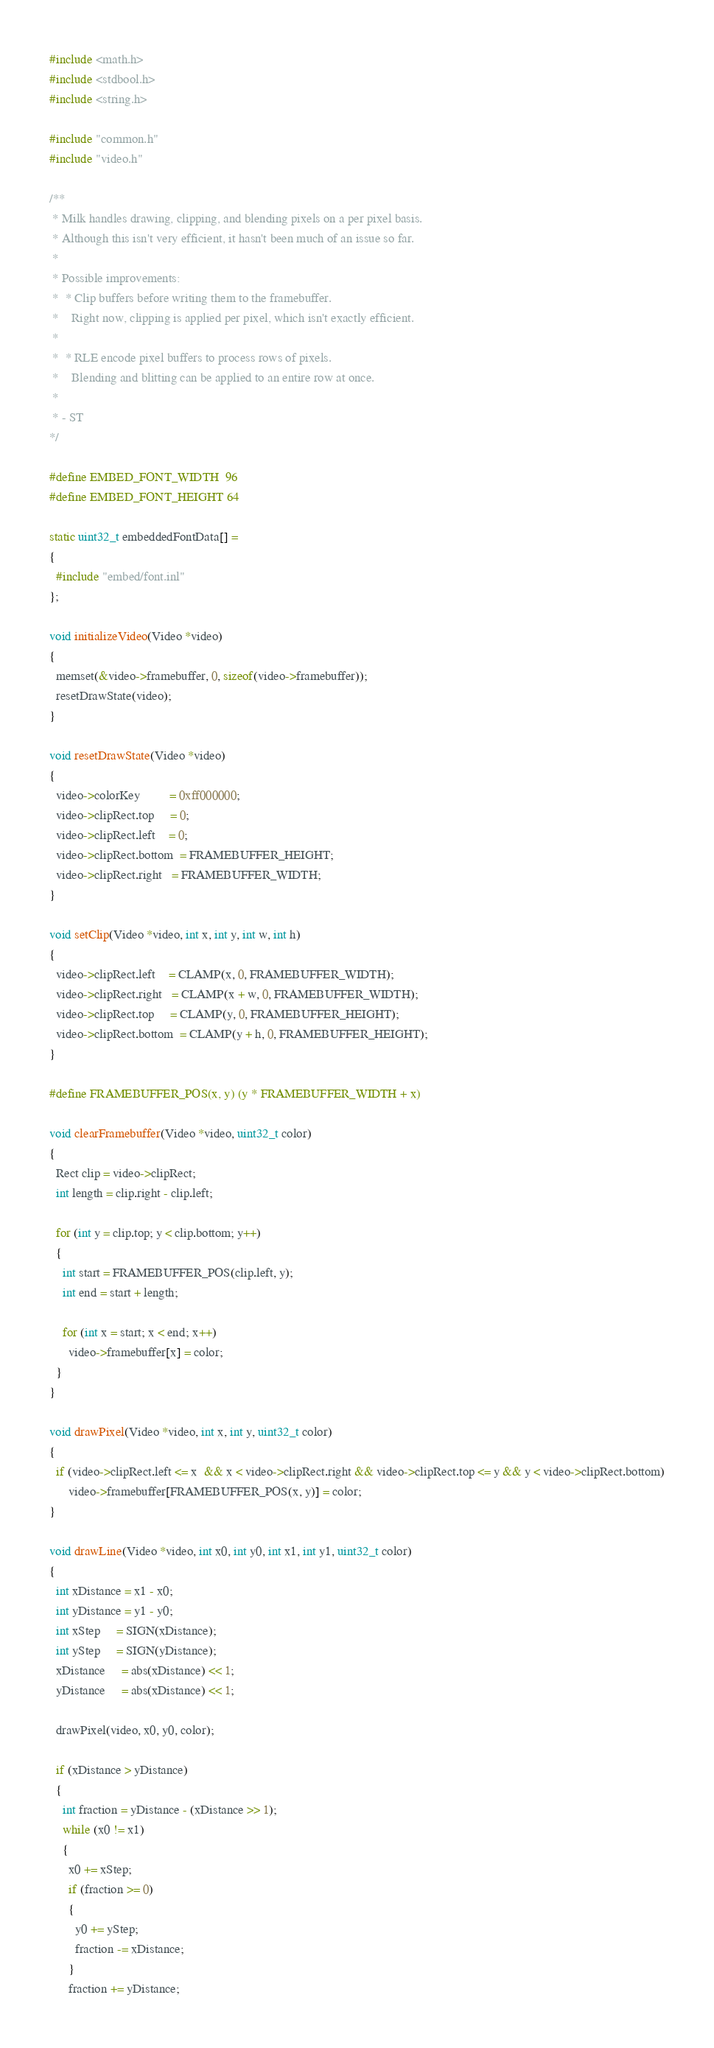<code> <loc_0><loc_0><loc_500><loc_500><_C_>#include <math.h>
#include <stdbool.h>
#include <string.h>

#include "common.h"
#include "video.h"

/**
 * Milk handles drawing, clipping, and blending pixels on a per pixel basis.
 * Although this isn't very efficient, it hasn't been much of an issue so far.
 *
 * Possible improvements:
 *  * Clip buffers before writing them to the framebuffer.
 *    Right now, clipping is applied per pixel, which isn't exactly efficient.
 *
 *  * RLE encode pixel buffers to process rows of pixels.
 *    Blending and blitting can be applied to an entire row at once.
 *
 * - ST
*/

#define EMBED_FONT_WIDTH  96
#define EMBED_FONT_HEIGHT 64

static uint32_t embeddedFontData[] =
{
  #include "embed/font.inl"
};

void initializeVideo(Video *video)
{
  memset(&video->framebuffer, 0, sizeof(video->framebuffer));
  resetDrawState(video);
}

void resetDrawState(Video *video)
{
  video->colorKey         = 0xff000000;
  video->clipRect.top     = 0;
  video->clipRect.left    = 0;
  video->clipRect.bottom  = FRAMEBUFFER_HEIGHT;
  video->clipRect.right   = FRAMEBUFFER_WIDTH;
}

void setClip(Video *video, int x, int y, int w, int h)
{
  video->clipRect.left    = CLAMP(x, 0, FRAMEBUFFER_WIDTH);
  video->clipRect.right   = CLAMP(x + w, 0, FRAMEBUFFER_WIDTH);
  video->clipRect.top     = CLAMP(y, 0, FRAMEBUFFER_HEIGHT);
  video->clipRect.bottom  = CLAMP(y + h, 0, FRAMEBUFFER_HEIGHT);
}

#define FRAMEBUFFER_POS(x, y) (y * FRAMEBUFFER_WIDTH + x)

void clearFramebuffer(Video *video, uint32_t color)
{
  Rect clip = video->clipRect;
  int length = clip.right - clip.left;

  for (int y = clip.top; y < clip.bottom; y++)
  {
    int start = FRAMEBUFFER_POS(clip.left, y);
    int end = start + length;

    for (int x = start; x < end; x++)
      video->framebuffer[x] = color;
  }
}

void drawPixel(Video *video, int x, int y, uint32_t color)
{
  if (video->clipRect.left <= x  && x < video->clipRect.right && video->clipRect.top <= y && y < video->clipRect.bottom)
      video->framebuffer[FRAMEBUFFER_POS(x, y)] = color;
}

void drawLine(Video *video, int x0, int y0, int x1, int y1, uint32_t color)
{
  int xDistance = x1 - x0;
  int yDistance = y1 - y0;
  int xStep     = SIGN(xDistance);
  int yStep     = SIGN(yDistance);
  xDistance     = abs(xDistance) << 1;
  yDistance     = abs(xDistance) << 1;

  drawPixel(video, x0, y0, color);

  if (xDistance > yDistance)
  {
    int fraction = yDistance - (xDistance >> 1);
    while (x0 != x1)
    {
      x0 += xStep;
      if (fraction >= 0)
      {
        y0 += yStep;
        fraction -= xDistance;
      }
      fraction += yDistance;</code> 